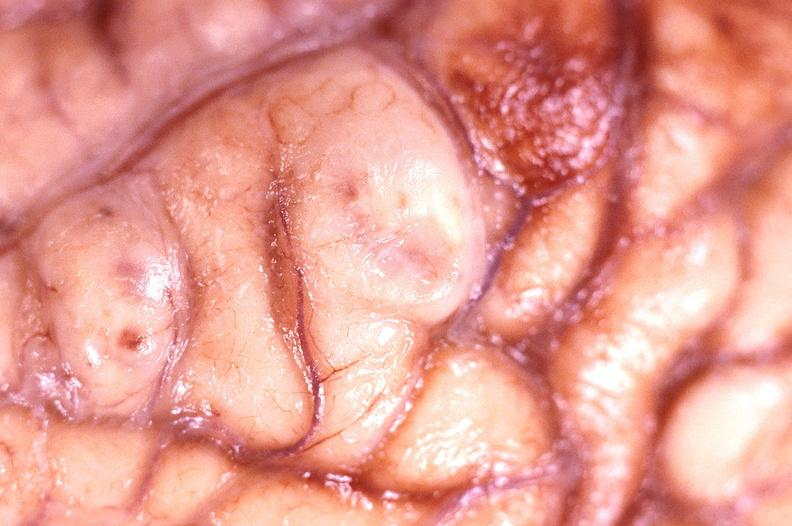does notochord show brain abscess?
Answer the question using a single word or phrase. No 